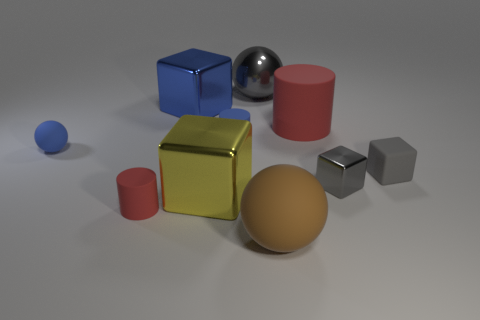There is another big thing that is the same material as the big red object; what color is it?
Provide a succinct answer. Brown. How many cubes have the same size as the gray rubber object?
Ensure brevity in your answer.  1. What number of other objects are the same color as the small shiny object?
Offer a very short reply. 2. Is the shape of the gray metal object on the left side of the big red thing the same as the small blue matte object in front of the blue matte cylinder?
Your answer should be very brief. Yes. There is a blue object that is the same size as the gray ball; what shape is it?
Make the answer very short. Cube. Is the number of large matte cylinders left of the large rubber cylinder the same as the number of big blue metal objects to the right of the yellow metal cube?
Offer a very short reply. Yes. Are the gray cube on the left side of the small gray matte cube and the small ball made of the same material?
Make the answer very short. No. What material is the red thing that is the same size as the metal ball?
Make the answer very short. Rubber. What number of other objects are the same material as the big brown ball?
Ensure brevity in your answer.  5. Is the size of the yellow metallic cube the same as the ball behind the large rubber cylinder?
Provide a short and direct response. Yes. 